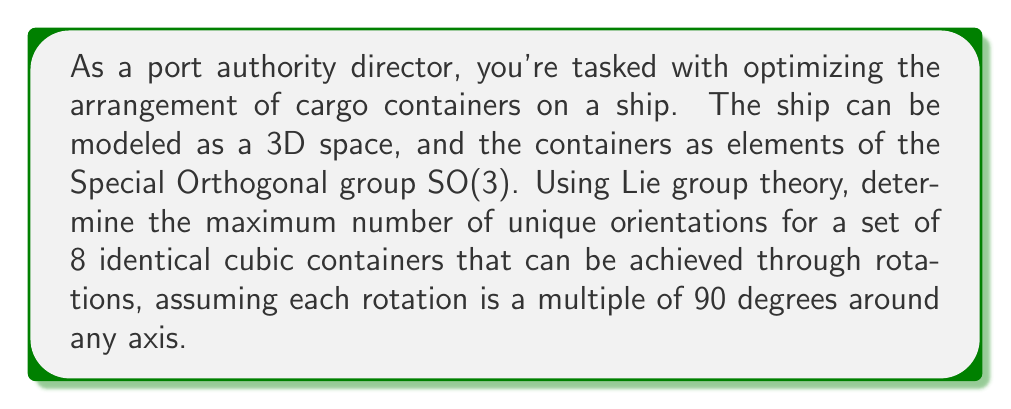Can you solve this math problem? To solve this problem, we need to understand and apply concepts from Lie group theory, specifically dealing with the Special Orthogonal group SO(3).

1. The Special Orthogonal group SO(3) represents all possible rotations in 3D space. In our case, we're restricted to rotations that are multiples of 90 degrees around any axis.

2. For a cubic container, there are 24 possible orientations that can be achieved through these rotations. This is because:
   - There are 6 faces that can be on top
   - For each top face, there are 4 possible rotations around the vertical axis

3. Mathematically, this group of rotations forms a finite subgroup of SO(3), known as the octahedral group or Oh.

4. The order of this group (number of elements) is 24, which corresponds to the 24 possible orientations of a cube.

5. Now, we need to consider how many unique arrangements we can create with 8 identical containers. This is equivalent to finding the number of ways to distribute 8 identical objects into 24 distinct boxes (orientations).

6. This problem can be solved using the stars and bars method from combinatorics. The formula for this is:

   $$ \binom{n+k-1}{k-1} $$

   where n is the number of identical objects (8 containers) and k is the number of distinct boxes (24 orientations).

7. Plugging in our values:

   $$ \binom{8+24-1}{24-1} = \binom{31}{23} $$

8. This can be calculated as:

   $$ \frac{31!}{23!(31-23)!} = \frac{31!}{23!8!} $$

9. Computing this large number:

   $$ \frac{31 * 30 * 29 * ... * 24}{8 * 7 * 6 * ... * 1} = 7,888,725 $$

Thus, there are 7,888,725 unique arrangements possible for the 8 containers.
Answer: 7,888,725 unique arrangements 